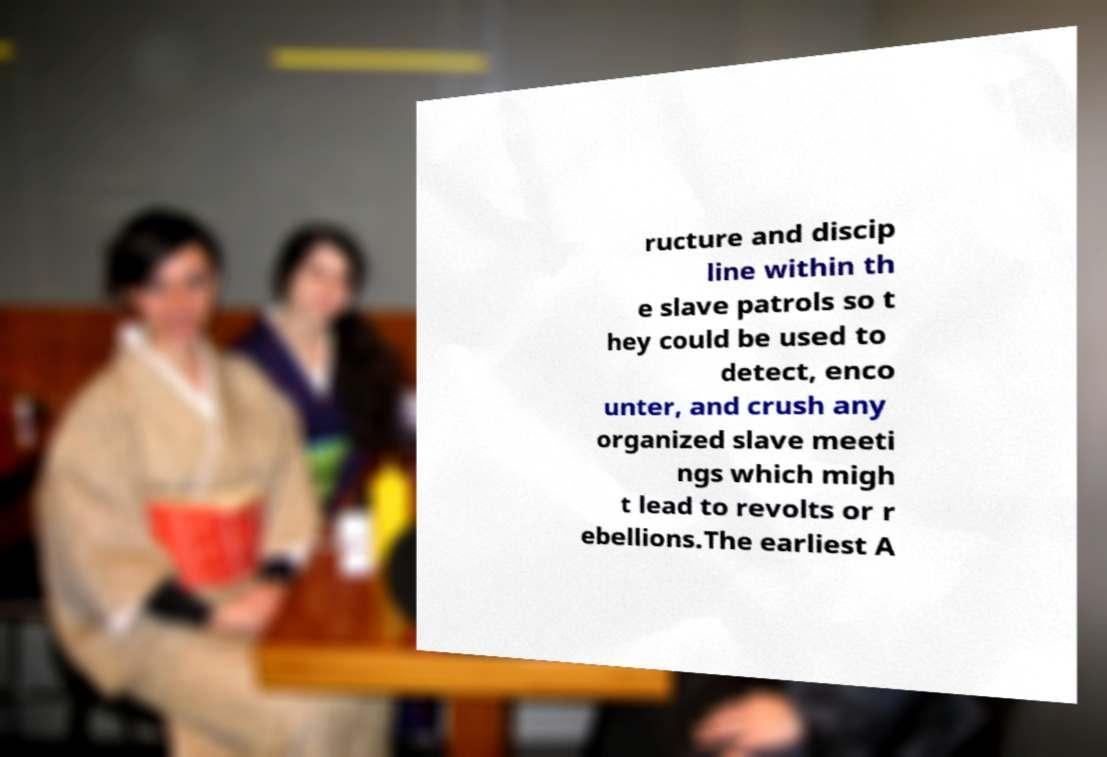Could you assist in decoding the text presented in this image and type it out clearly? ructure and discip line within th e slave patrols so t hey could be used to detect, enco unter, and crush any organized slave meeti ngs which migh t lead to revolts or r ebellions.The earliest A 